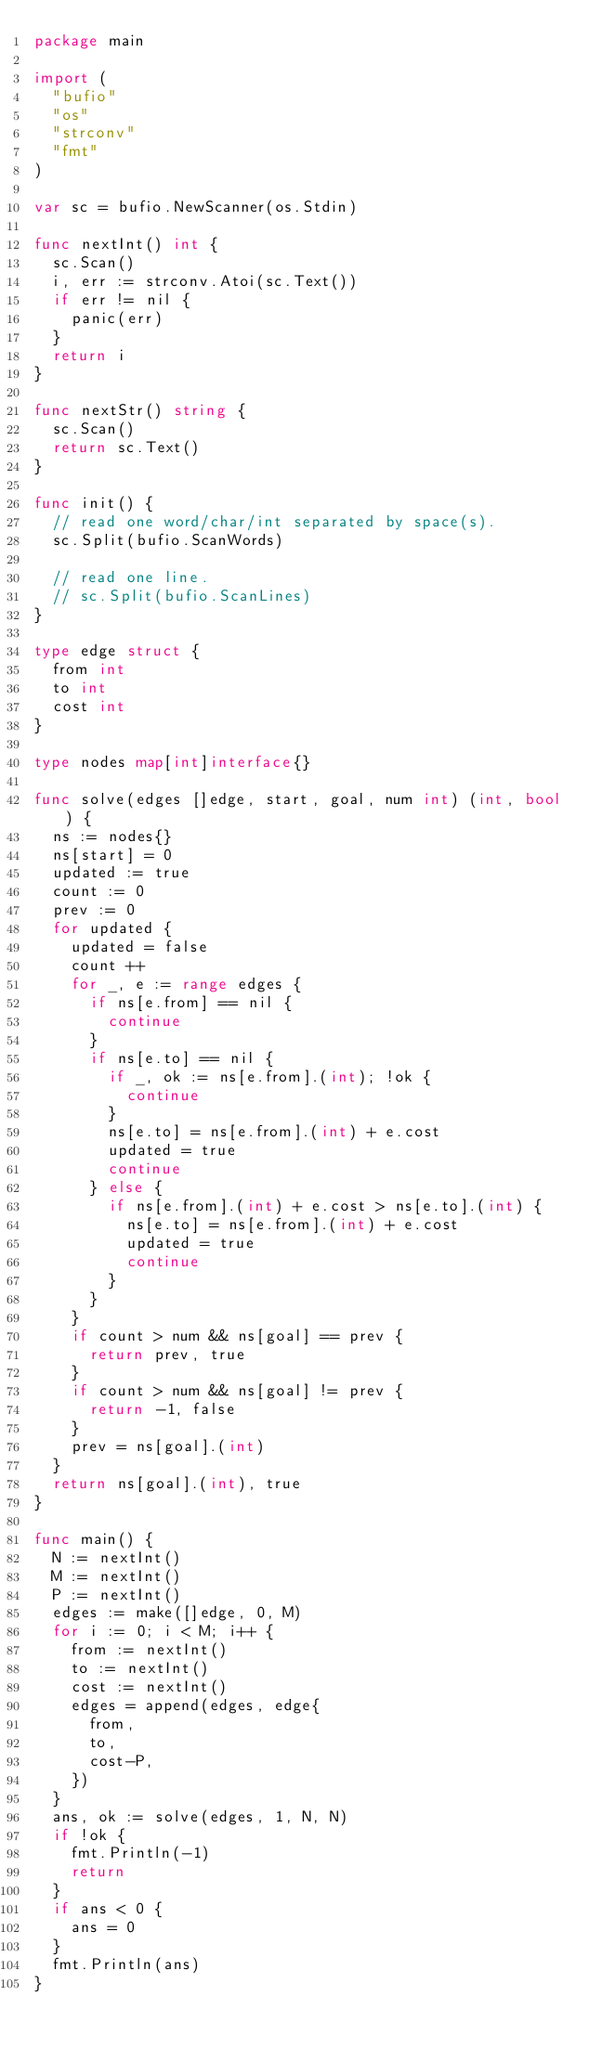Convert code to text. <code><loc_0><loc_0><loc_500><loc_500><_Go_>package main

import (
	"bufio"
	"os"
	"strconv"
	"fmt"
)

var sc = bufio.NewScanner(os.Stdin)

func nextInt() int {
	sc.Scan()
	i, err := strconv.Atoi(sc.Text())
	if err != nil {
		panic(err)
	}
	return i
}

func nextStr() string {
	sc.Scan()
	return sc.Text()
}

func init() {
	// read one word/char/int separated by space(s).
	sc.Split(bufio.ScanWords)

	// read one line.
	// sc.Split(bufio.ScanLines)
}

type edge struct {
	from int
	to int
	cost int
}

type nodes map[int]interface{}

func solve(edges []edge, start, goal, num int) (int, bool) {
	ns := nodes{}
	ns[start] = 0
	updated := true
	count := 0
	prev := 0
	for updated {
		updated = false
		count ++
		for _, e := range edges {
			if ns[e.from] == nil {
				continue
			}
			if ns[e.to] == nil {
				if _, ok := ns[e.from].(int); !ok {
					continue
				}
				ns[e.to] = ns[e.from].(int) + e.cost
				updated = true
				continue
			} else {
				if ns[e.from].(int) + e.cost > ns[e.to].(int) {
					ns[e.to] = ns[e.from].(int) + e.cost
					updated = true
					continue
				}
			}
		}
		if count > num && ns[goal] == prev {
			return prev, true
		}
		if count > num && ns[goal] != prev {
			return -1, false
		}
		prev = ns[goal].(int)
	}
	return ns[goal].(int), true
}

func main() {
	N := nextInt()
	M := nextInt()
	P := nextInt()
	edges := make([]edge, 0, M)
	for i := 0; i < M; i++ {
		from := nextInt()
		to := nextInt()
		cost := nextInt()
		edges = append(edges, edge{
			from,
			to,
			cost-P,
		})
	}
	ans, ok := solve(edges, 1, N, N)
	if !ok {
		fmt.Println(-1)
		return
	}
	if ans < 0 {
		ans = 0
	}
	fmt.Println(ans)
}</code> 